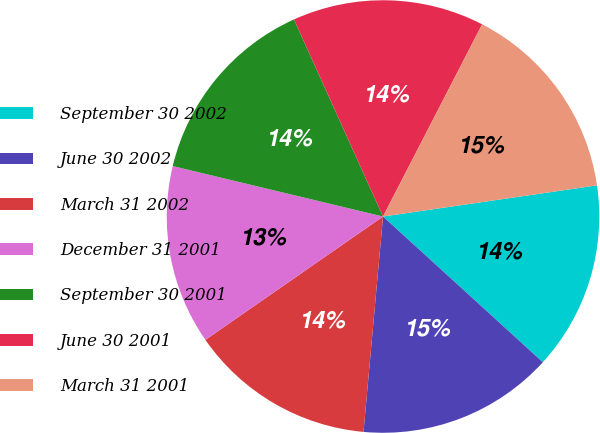Convert chart. <chart><loc_0><loc_0><loc_500><loc_500><pie_chart><fcel>September 30 2002<fcel>June 30 2002<fcel>March 31 2002<fcel>December 31 2001<fcel>September 30 2001<fcel>June 30 2001<fcel>March 31 2001<nl><fcel>14.07%<fcel>14.67%<fcel>13.9%<fcel>13.41%<fcel>14.5%<fcel>14.33%<fcel>15.12%<nl></chart> 